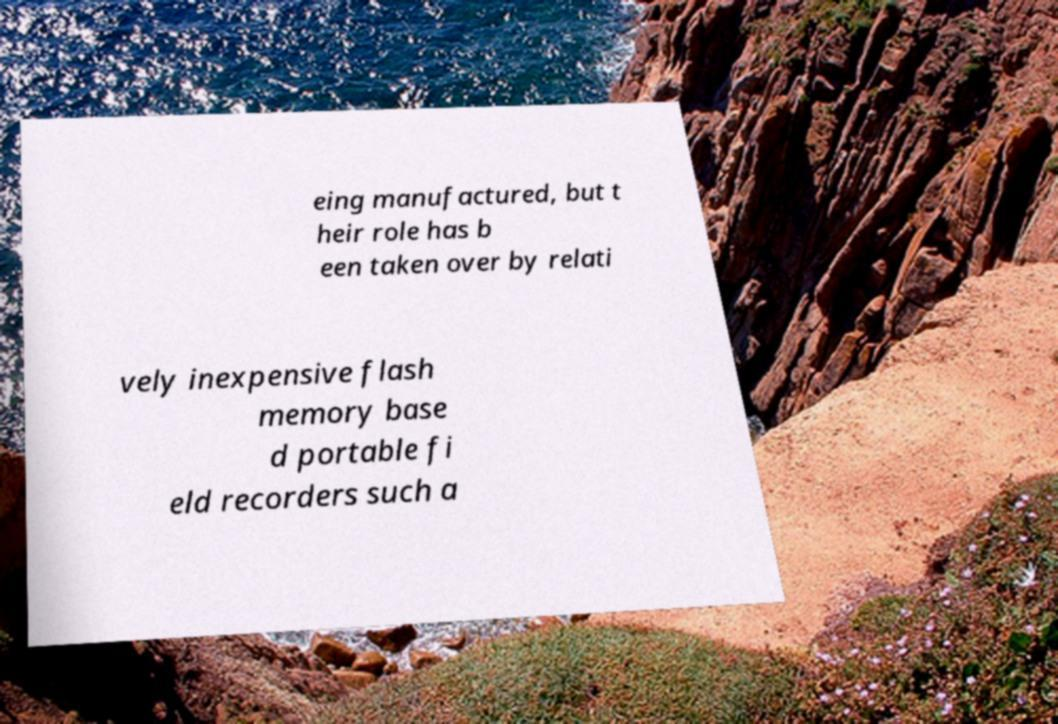Can you accurately transcribe the text from the provided image for me? eing manufactured, but t heir role has b een taken over by relati vely inexpensive flash memory base d portable fi eld recorders such a 